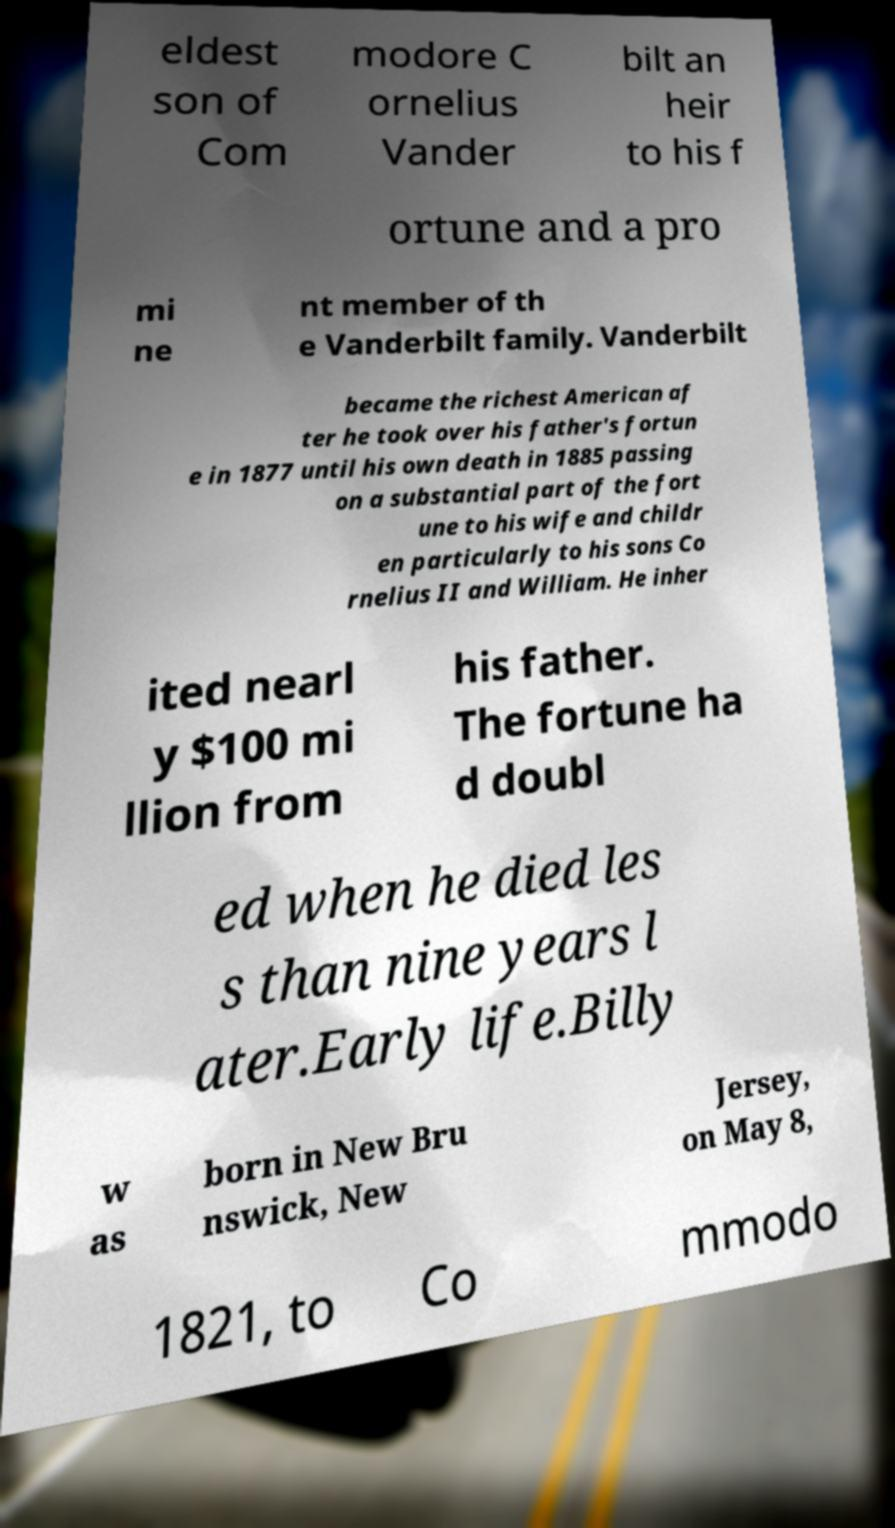Could you assist in decoding the text presented in this image and type it out clearly? eldest son of Com modore C ornelius Vander bilt an heir to his f ortune and a pro mi ne nt member of th e Vanderbilt family. Vanderbilt became the richest American af ter he took over his father's fortun e in 1877 until his own death in 1885 passing on a substantial part of the fort une to his wife and childr en particularly to his sons Co rnelius II and William. He inher ited nearl y $100 mi llion from his father. The fortune ha d doubl ed when he died les s than nine years l ater.Early life.Billy w as born in New Bru nswick, New Jersey, on May 8, 1821, to Co mmodo 